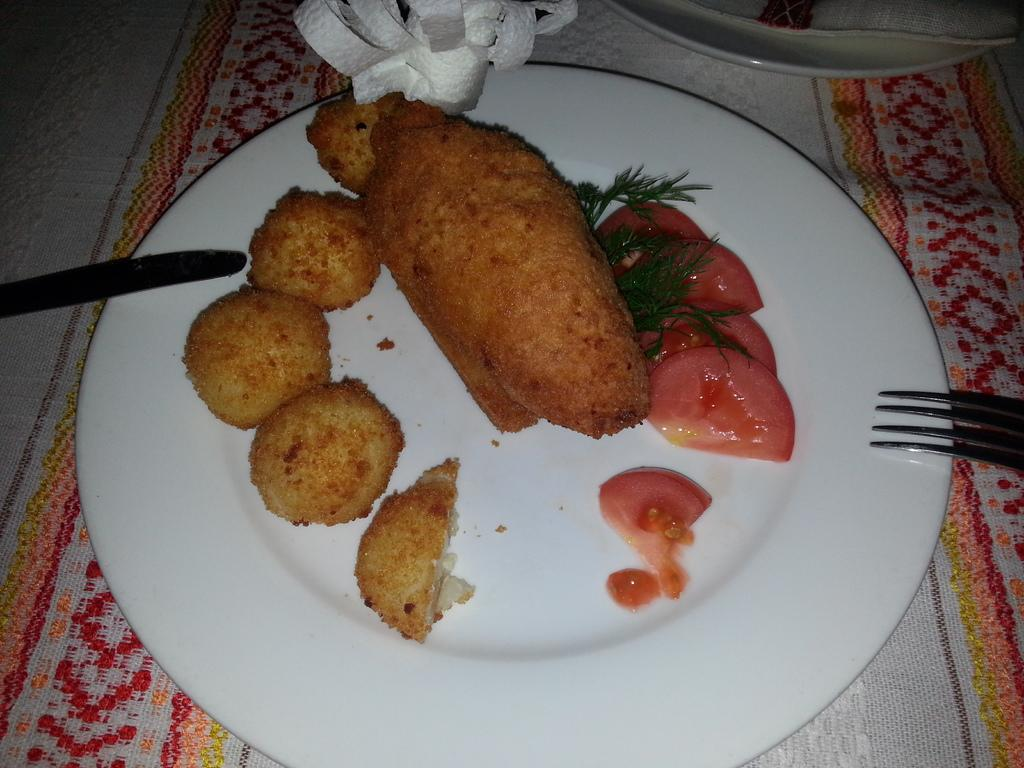What is on the plate that is visible in the image? There are food items on the plate, including pieces of tomato and leaves. What is the plate placed on in the image? The plate is on a towel in the image. What utensils are near the plate in the image? There is a knife and a fork near the plate in the image. What type of umbrella is being used to protect the food from the rain in the image? There is no umbrella present in the image, and the food is not being protected from the rain. 